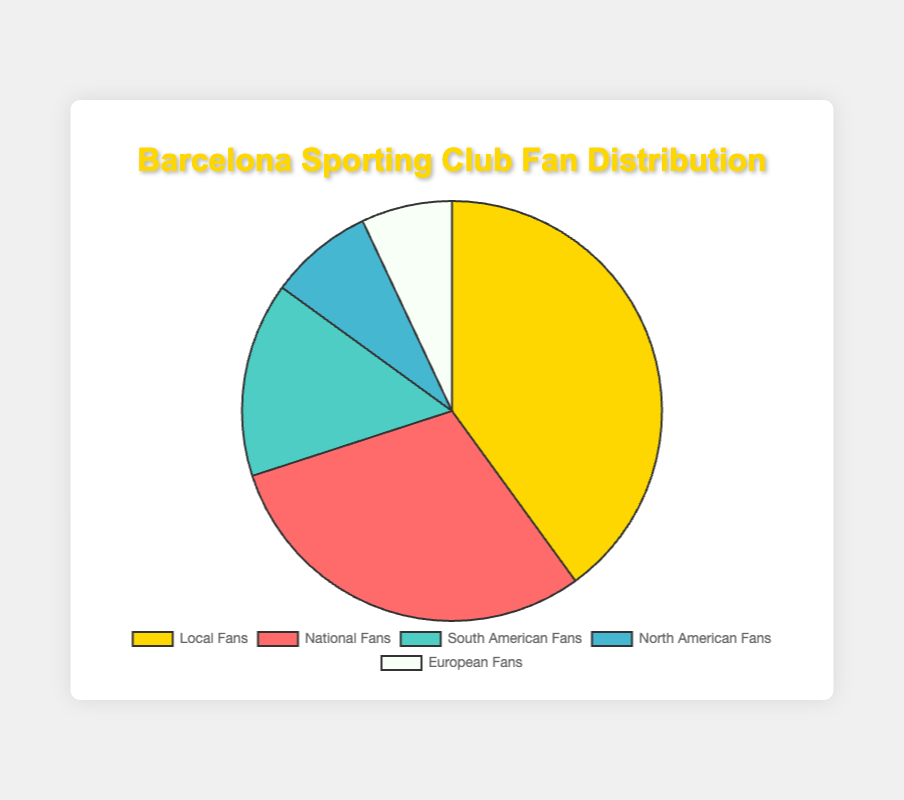What percentage of fans are local fans? The chart shows that local fans represent 40% of the total.
Answer: 40% Which fan group is the smallest? The chart indicates that European fans, making up 7%, represent the smallest group.
Answer: European fans Is the percentage of National Fans higher than that of South American Fans? The chart shows that national fans make up 30%, whereas South American fans account for 15%, so National fans have a higher percentage.
Answer: Yes What is the combined percentage of North American and European fans? The chart shows that North American fans represent 8% and European fans represent 7%, so their combined total is 8% + 7% = 15%.
Answer: 15% How many more percentage points do Local Fans have compared to National Fans? Local fans have 40%, and National fans have 30%. The difference is 40% - 30% = 10%.
Answer: 10 percentage points What proportion of the pie chart is dedicated to South American Fans? South American fans account for 15% of the total pie chart.
Answer: 15% Which fan group has the second highest proportion in the chart? National fans have the second highest proportion at 30%, following local fans.
Answer: National fans Which color represents the largest fan group in the chart? The largest fan group, Local Fans (40%), is represented by the golden yellow color.
Answer: Golden yellow How does the proportion of South American fans compare to North American fans? South American fans make up 15%, while North American fans account for 8%. Therefore, South American fans have a higher proportion.
Answer: South American fans have a higher proportion What is the average percentage of the three smallest fan groups? The three smallest fan groups are South American (15%), North American (8%), and European (7%). Their average percentage is (15 + 8 + 7) / 3 = 10%.
Answer: 10% 